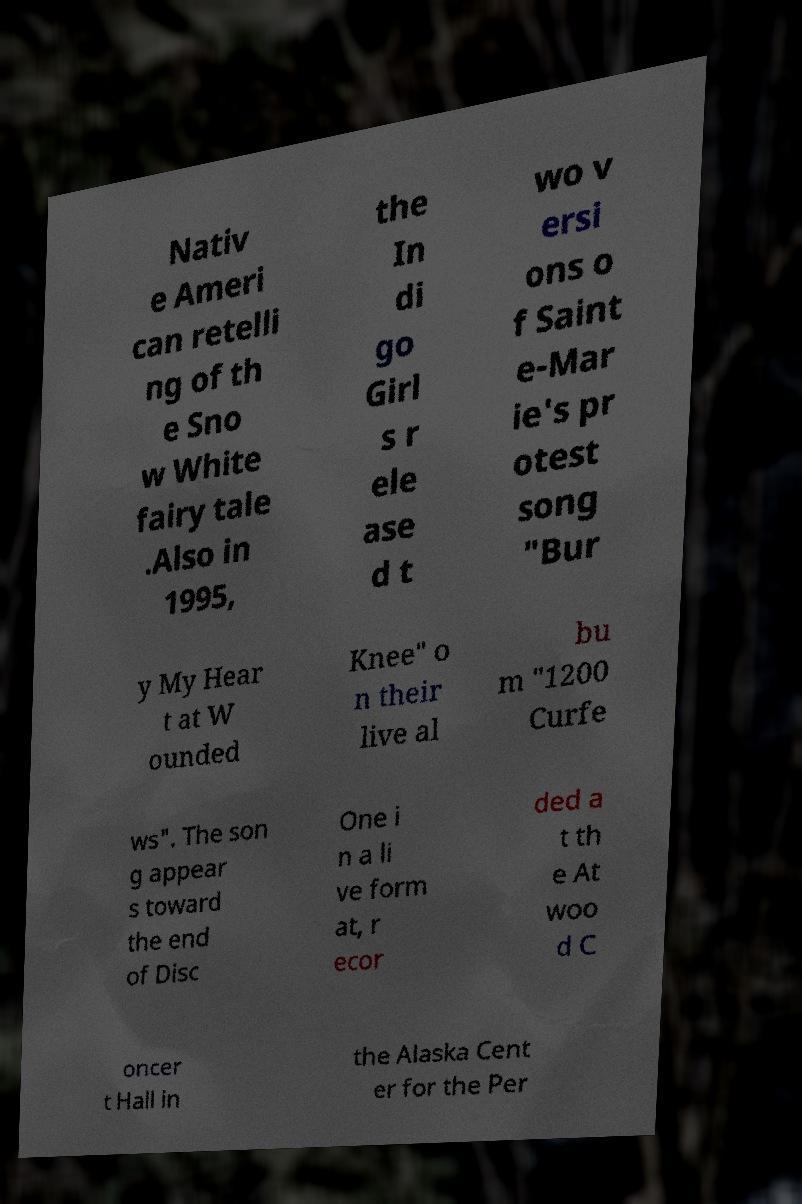Please identify and transcribe the text found in this image. Nativ e Ameri can retelli ng of th e Sno w White fairy tale .Also in 1995, the In di go Girl s r ele ase d t wo v ersi ons o f Saint e-Mar ie's pr otest song "Bur y My Hear t at W ounded Knee" o n their live al bu m "1200 Curfe ws". The son g appear s toward the end of Disc One i n a li ve form at, r ecor ded a t th e At woo d C oncer t Hall in the Alaska Cent er for the Per 